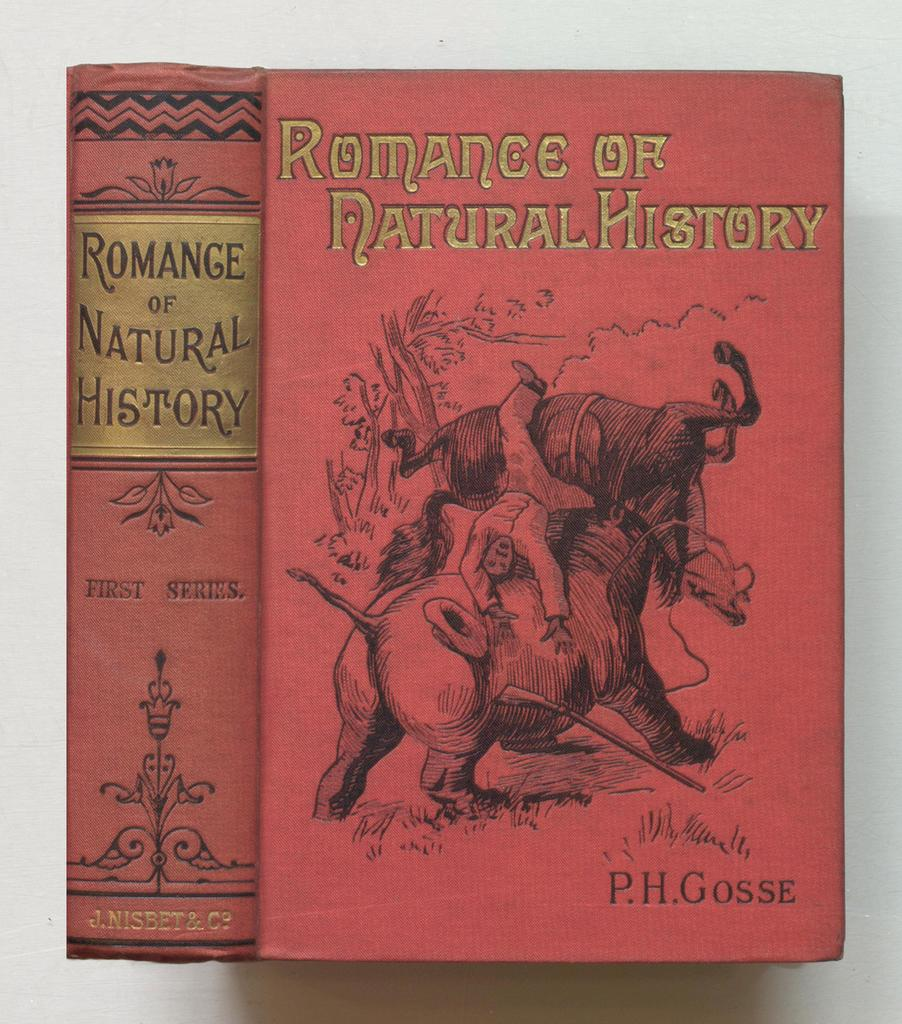<image>
Describe the image concisely. Romance of Natural History was written by P.H. Gosse. 